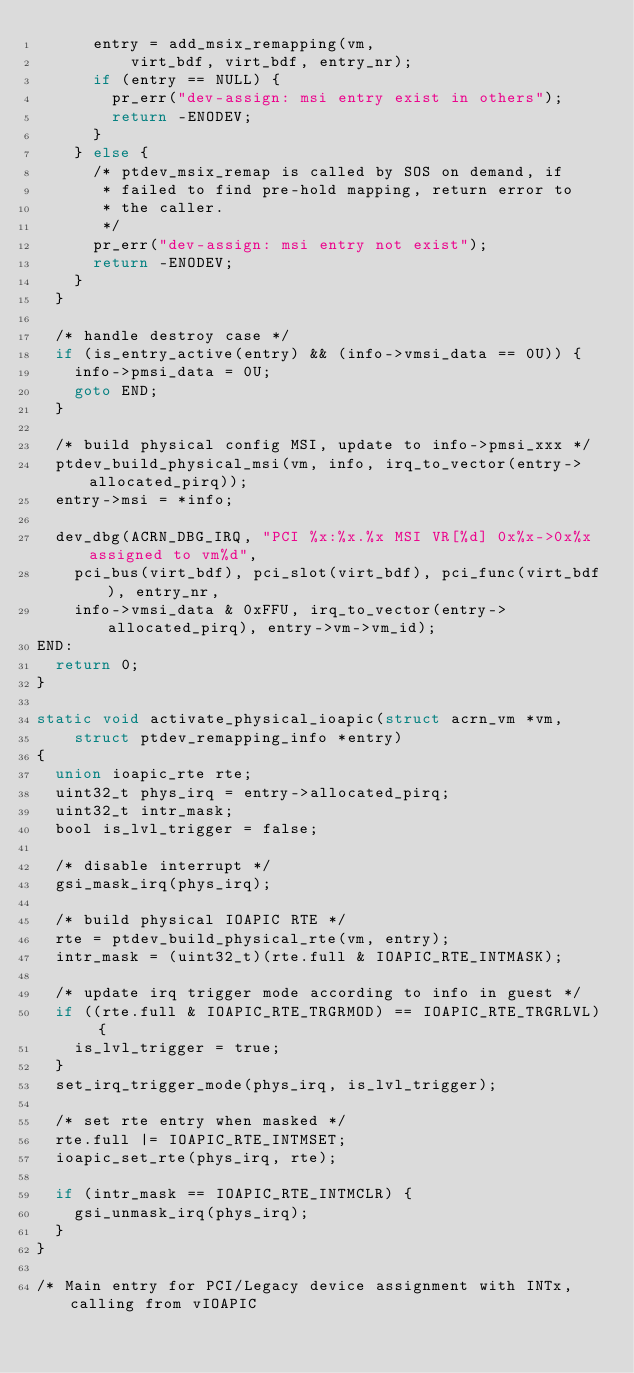<code> <loc_0><loc_0><loc_500><loc_500><_C_>			entry = add_msix_remapping(vm,
					virt_bdf, virt_bdf, entry_nr);
			if (entry == NULL) {
				pr_err("dev-assign: msi entry exist in others");
				return -ENODEV;
			}
		} else {
			/* ptdev_msix_remap is called by SOS on demand, if
			 * failed to find pre-hold mapping, return error to
			 * the caller.
			 */
			pr_err("dev-assign: msi entry not exist");
			return -ENODEV;
		}
	}

	/* handle destroy case */
	if (is_entry_active(entry) && (info->vmsi_data == 0U)) {
		info->pmsi_data = 0U;
		goto END;
	}

	/* build physical config MSI, update to info->pmsi_xxx */
	ptdev_build_physical_msi(vm, info, irq_to_vector(entry->allocated_pirq));
	entry->msi = *info;

	dev_dbg(ACRN_DBG_IRQ, "PCI %x:%x.%x MSI VR[%d] 0x%x->0x%x assigned to vm%d",
		pci_bus(virt_bdf), pci_slot(virt_bdf), pci_func(virt_bdf), entry_nr,
		info->vmsi_data & 0xFFU, irq_to_vector(entry->allocated_pirq), entry->vm->vm_id);
END:
	return 0;
}

static void activate_physical_ioapic(struct acrn_vm *vm,
		struct ptdev_remapping_info *entry)
{
	union ioapic_rte rte;
	uint32_t phys_irq = entry->allocated_pirq;
	uint32_t intr_mask;
	bool is_lvl_trigger = false;

	/* disable interrupt */
	gsi_mask_irq(phys_irq);

	/* build physical IOAPIC RTE */
	rte = ptdev_build_physical_rte(vm, entry);
	intr_mask = (uint32_t)(rte.full & IOAPIC_RTE_INTMASK);

	/* update irq trigger mode according to info in guest */
	if ((rte.full & IOAPIC_RTE_TRGRMOD) == IOAPIC_RTE_TRGRLVL) {
		is_lvl_trigger = true;
	}
	set_irq_trigger_mode(phys_irq, is_lvl_trigger);

	/* set rte entry when masked */
	rte.full |= IOAPIC_RTE_INTMSET;
	ioapic_set_rte(phys_irq, rte);

	if (intr_mask == IOAPIC_RTE_INTMCLR) {
		gsi_unmask_irq(phys_irq);
	}
}

/* Main entry for PCI/Legacy device assignment with INTx, calling from vIOAPIC</code> 